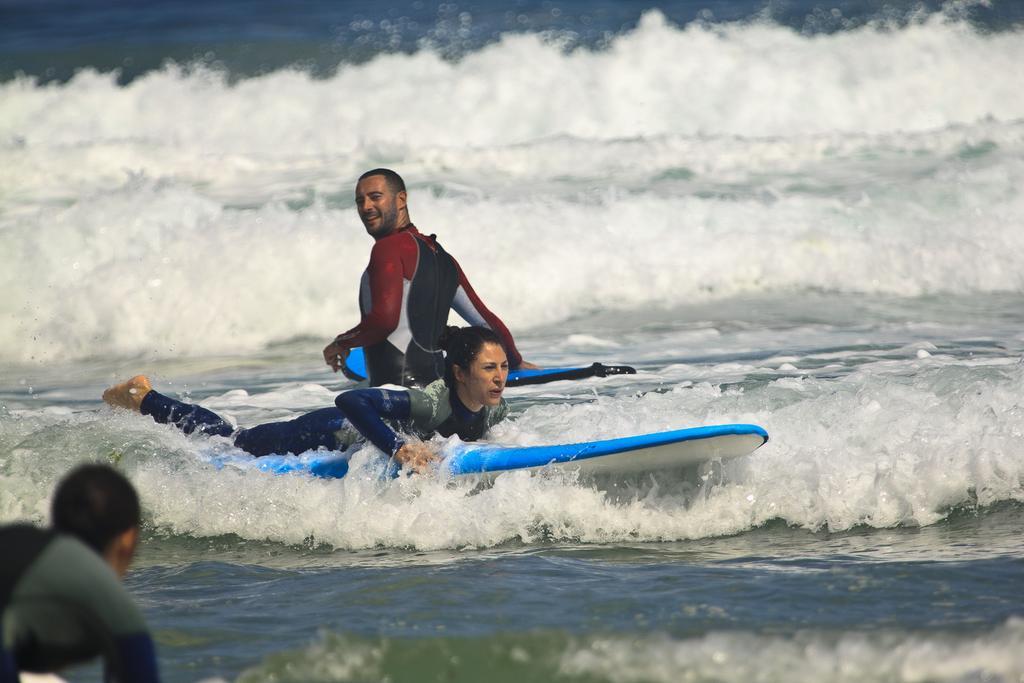Describe this image in one or two sentences. The picture is taken on the sea where one woman is surfing on the board wearing blue suit and one man is standing and holding board and there is water in the picture. 